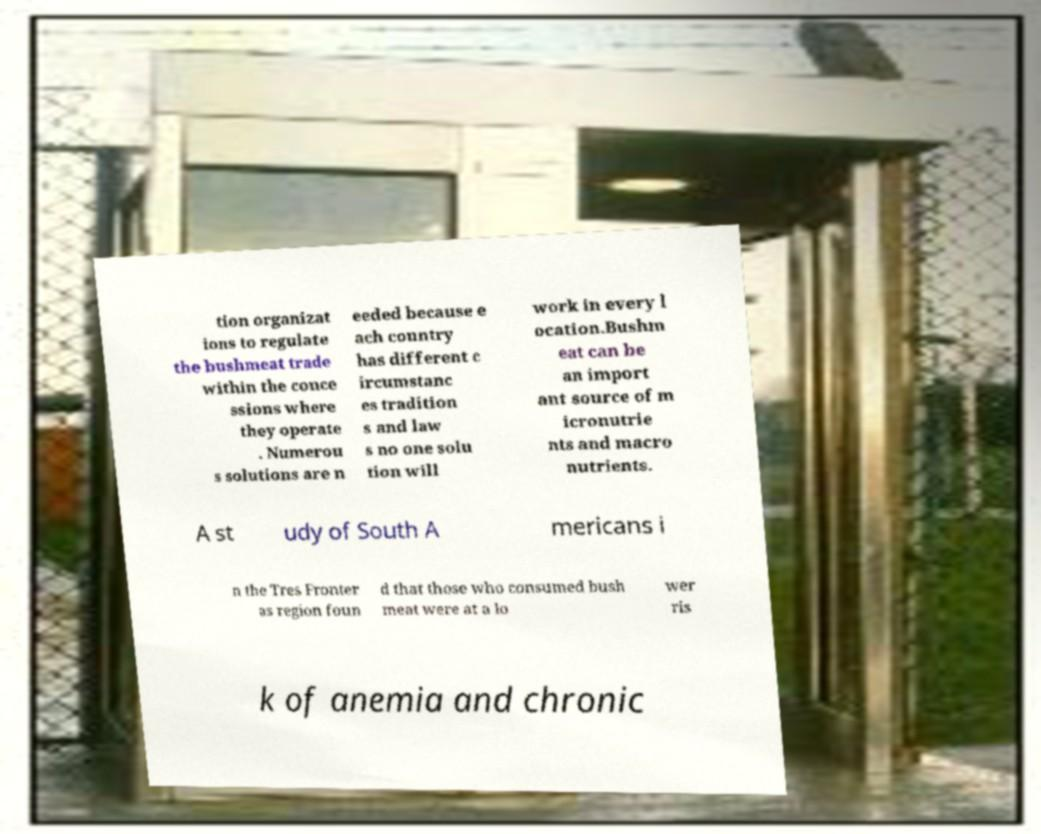Could you assist in decoding the text presented in this image and type it out clearly? tion organizat ions to regulate the bushmeat trade within the conce ssions where they operate . Numerou s solutions are n eeded because e ach country has different c ircumstanc es tradition s and law s no one solu tion will work in every l ocation.Bushm eat can be an import ant source of m icronutrie nts and macro nutrients. A st udy of South A mericans i n the Tres Fronter as region foun d that those who consumed bush meat were at a lo wer ris k of anemia and chronic 